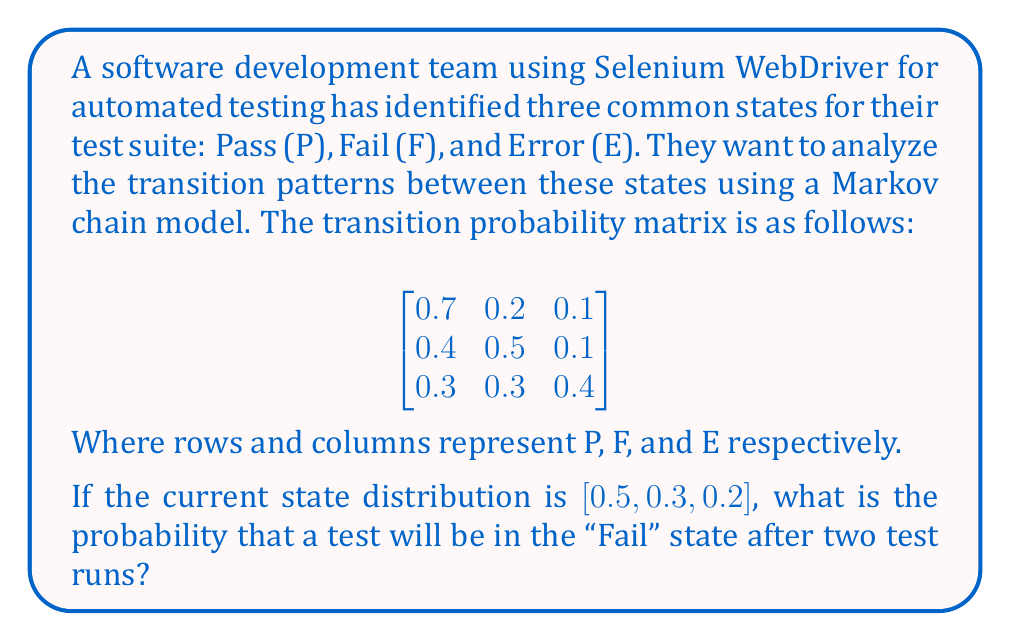Help me with this question. To solve this problem, we'll use the Markov chain model and matrix multiplication. Let's break it down step-by-step:

1. The initial state distribution is given as:
   $$\pi_0 = [0.5, 0.3, 0.2]$$

2. The transition probability matrix is:
   $$P = \begin{bmatrix}
   0.7 & 0.2 & 0.1 \\
   0.4 & 0.5 & 0.1 \\
   0.3 & 0.3 & 0.4
   \end{bmatrix}$$

3. To find the state distribution after two test runs, we need to multiply the initial distribution by the transition matrix twice:
   $$\pi_2 = \pi_0 \cdot P^2$$

4. First, let's calculate $P^2$:
   $$P^2 = P \cdot P = \begin{bmatrix}
   0.7 & 0.2 & 0.1 \\
   0.4 & 0.5 & 0.1 \\
   0.3 & 0.3 & 0.4
   \end{bmatrix} \cdot \begin{bmatrix}
   0.7 & 0.2 & 0.1 \\
   0.4 & 0.5 & 0.1 \\
   0.3 & 0.3 & 0.4
   \end{bmatrix}$$

   $$P^2 = \begin{bmatrix}
   0.61 & 0.26 & 0.13 \\
   0.53 & 0.33 & 0.14 \\
   0.43 & 0.33 & 0.24
   \end{bmatrix}$$

5. Now, we multiply the initial distribution by $P^2$:
   $$\pi_2 = [0.5, 0.3, 0.2] \cdot \begin{bmatrix}
   0.61 & 0.26 & 0.13 \\
   0.53 & 0.33 & 0.14 \\
   0.43 & 0.33 & 0.24
   \end{bmatrix}$$

6. Performing the matrix multiplication:
   $$\pi_2 = [0.555, 0.29, 0.155]$$

7. The probability of being in the "Fail" state (second element) after two test runs is 0.29 or 29%.
Answer: 0.29 